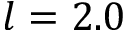Convert formula to latex. <formula><loc_0><loc_0><loc_500><loc_500>l = 2 . 0</formula> 